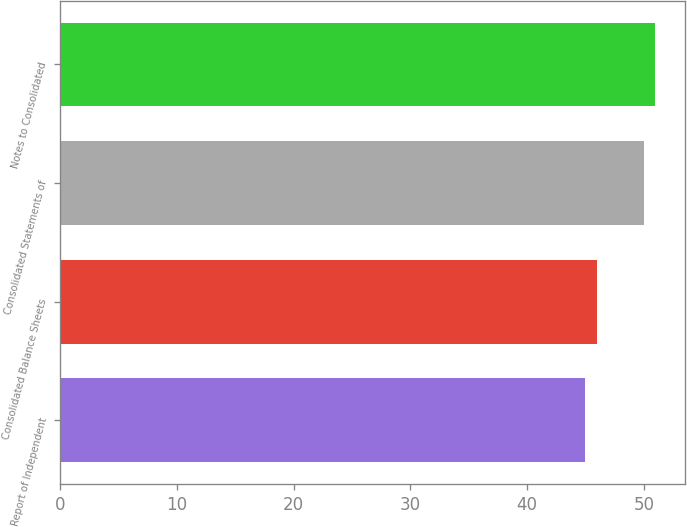Convert chart. <chart><loc_0><loc_0><loc_500><loc_500><bar_chart><fcel>Report of Independent<fcel>Consolidated Balance Sheets<fcel>Consolidated Statements of<fcel>Notes to Consolidated<nl><fcel>45<fcel>46<fcel>50<fcel>51<nl></chart> 